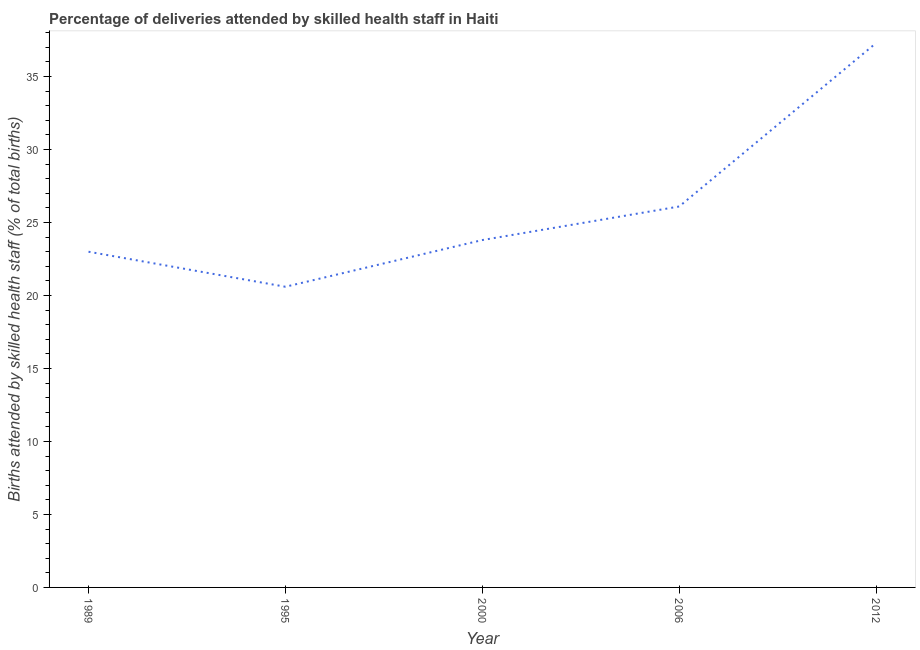What is the number of births attended by skilled health staff in 2012?
Give a very brief answer. 37.3. Across all years, what is the maximum number of births attended by skilled health staff?
Keep it short and to the point. 37.3. Across all years, what is the minimum number of births attended by skilled health staff?
Your answer should be compact. 20.6. In which year was the number of births attended by skilled health staff maximum?
Make the answer very short. 2012. What is the sum of the number of births attended by skilled health staff?
Offer a terse response. 130.8. What is the difference between the number of births attended by skilled health staff in 1989 and 2000?
Offer a very short reply. -0.8. What is the average number of births attended by skilled health staff per year?
Your answer should be very brief. 26.16. What is the median number of births attended by skilled health staff?
Offer a terse response. 23.8. What is the ratio of the number of births attended by skilled health staff in 2000 to that in 2006?
Provide a succinct answer. 0.91. Is the difference between the number of births attended by skilled health staff in 2000 and 2006 greater than the difference between any two years?
Make the answer very short. No. What is the difference between the highest and the second highest number of births attended by skilled health staff?
Offer a terse response. 11.2. Is the sum of the number of births attended by skilled health staff in 1995 and 2012 greater than the maximum number of births attended by skilled health staff across all years?
Give a very brief answer. Yes. What is the difference between the highest and the lowest number of births attended by skilled health staff?
Give a very brief answer. 16.7. In how many years, is the number of births attended by skilled health staff greater than the average number of births attended by skilled health staff taken over all years?
Your response must be concise. 1. How many lines are there?
Make the answer very short. 1. Does the graph contain grids?
Provide a short and direct response. No. What is the title of the graph?
Offer a very short reply. Percentage of deliveries attended by skilled health staff in Haiti. What is the label or title of the X-axis?
Your response must be concise. Year. What is the label or title of the Y-axis?
Offer a terse response. Births attended by skilled health staff (% of total births). What is the Births attended by skilled health staff (% of total births) of 1989?
Your response must be concise. 23. What is the Births attended by skilled health staff (% of total births) of 1995?
Ensure brevity in your answer.  20.6. What is the Births attended by skilled health staff (% of total births) of 2000?
Keep it short and to the point. 23.8. What is the Births attended by skilled health staff (% of total births) of 2006?
Provide a succinct answer. 26.1. What is the Births attended by skilled health staff (% of total births) of 2012?
Ensure brevity in your answer.  37.3. What is the difference between the Births attended by skilled health staff (% of total births) in 1989 and 1995?
Make the answer very short. 2.4. What is the difference between the Births attended by skilled health staff (% of total births) in 1989 and 2006?
Your answer should be very brief. -3.1. What is the difference between the Births attended by skilled health staff (% of total births) in 1989 and 2012?
Give a very brief answer. -14.3. What is the difference between the Births attended by skilled health staff (% of total births) in 1995 and 2006?
Provide a short and direct response. -5.5. What is the difference between the Births attended by skilled health staff (% of total births) in 1995 and 2012?
Offer a very short reply. -16.7. What is the difference between the Births attended by skilled health staff (% of total births) in 2000 and 2006?
Your response must be concise. -2.3. What is the difference between the Births attended by skilled health staff (% of total births) in 2000 and 2012?
Provide a succinct answer. -13.5. What is the ratio of the Births attended by skilled health staff (% of total births) in 1989 to that in 1995?
Offer a very short reply. 1.12. What is the ratio of the Births attended by skilled health staff (% of total births) in 1989 to that in 2000?
Your response must be concise. 0.97. What is the ratio of the Births attended by skilled health staff (% of total births) in 1989 to that in 2006?
Make the answer very short. 0.88. What is the ratio of the Births attended by skilled health staff (% of total births) in 1989 to that in 2012?
Your answer should be compact. 0.62. What is the ratio of the Births attended by skilled health staff (% of total births) in 1995 to that in 2000?
Give a very brief answer. 0.87. What is the ratio of the Births attended by skilled health staff (% of total births) in 1995 to that in 2006?
Offer a terse response. 0.79. What is the ratio of the Births attended by skilled health staff (% of total births) in 1995 to that in 2012?
Provide a succinct answer. 0.55. What is the ratio of the Births attended by skilled health staff (% of total births) in 2000 to that in 2006?
Provide a succinct answer. 0.91. What is the ratio of the Births attended by skilled health staff (% of total births) in 2000 to that in 2012?
Your response must be concise. 0.64. 